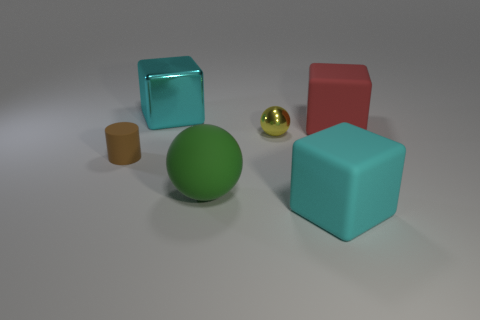Is there a rubber cube of the same color as the large shiny cube?
Give a very brief answer. Yes. There is a cube in front of the shiny thing in front of the metallic thing behind the tiny shiny object; what size is it?
Give a very brief answer. Large. Do the large red rubber object and the small object that is left of the yellow shiny thing have the same shape?
Offer a very short reply. No. What number of other things are there of the same size as the rubber cylinder?
Make the answer very short. 1. What size is the matte cube that is in front of the large red rubber object?
Offer a very short reply. Large. How many cyan cubes have the same material as the large red thing?
Provide a short and direct response. 1. There is a big cyan object that is in front of the small brown thing; does it have the same shape as the brown rubber thing?
Give a very brief answer. No. There is a cyan object that is in front of the tiny shiny sphere; what shape is it?
Provide a succinct answer. Cube. The matte block that is the same color as the large metallic cube is what size?
Ensure brevity in your answer.  Large. What material is the brown object?
Your response must be concise. Rubber. 